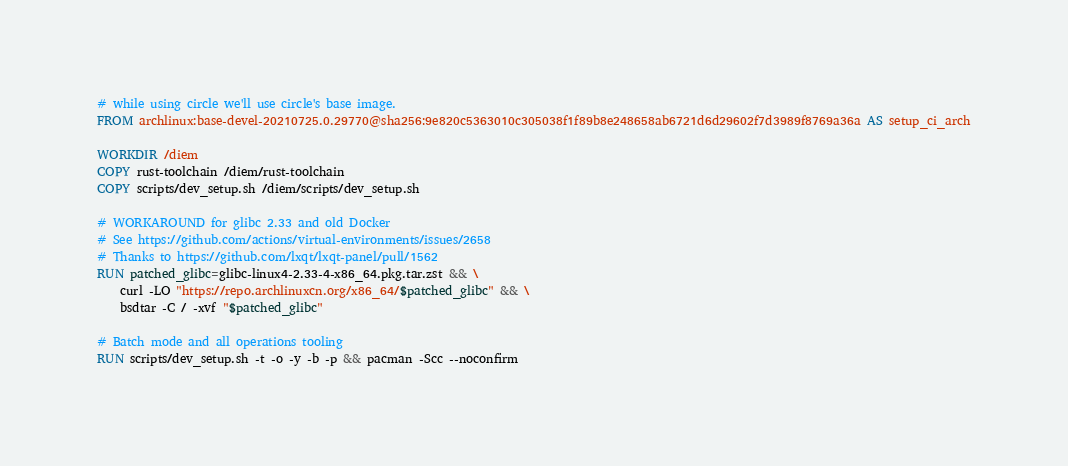<code> <loc_0><loc_0><loc_500><loc_500><_Dockerfile_># while using circle we'll use circle's base image.
FROM archlinux:base-devel-20210725.0.29770@sha256:9e820c5363010c305038f1f89b8e248658ab6721d6d29602f7d3989f8769a36a AS setup_ci_arch

WORKDIR /diem
COPY rust-toolchain /diem/rust-toolchain
COPY scripts/dev_setup.sh /diem/scripts/dev_setup.sh

# WORKAROUND for glibc 2.33 and old Docker
# See https://github.com/actions/virtual-environments/issues/2658
# Thanks to https://github.com/lxqt/lxqt-panel/pull/1562
RUN patched_glibc=glibc-linux4-2.33-4-x86_64.pkg.tar.zst && \
    curl -LO "https://repo.archlinuxcn.org/x86_64/$patched_glibc" && \
    bsdtar -C / -xvf "$patched_glibc"

# Batch mode and all operations tooling
RUN scripts/dev_setup.sh -t -o -y -b -p && pacman -Scc --noconfirm</code> 